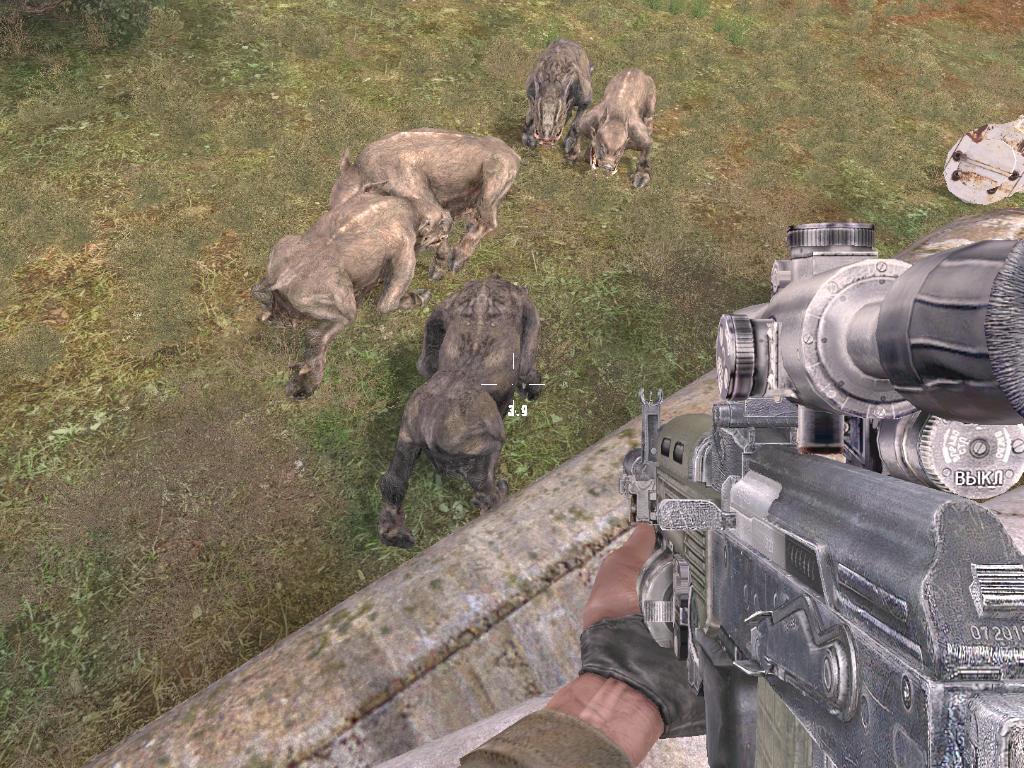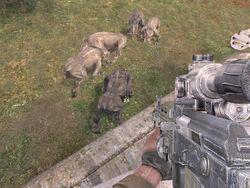The first image is the image on the left, the second image is the image on the right. Examine the images to the left and right. Is the description "At least one image is not of pigs." accurate? Answer yes or no. Yes. 